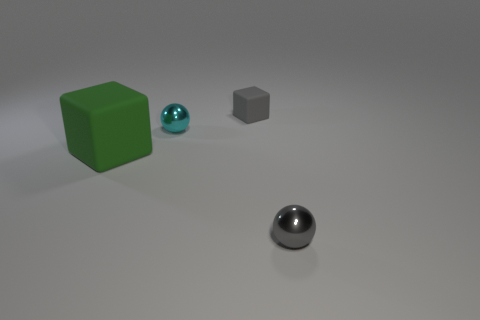What shape is the small thing that is made of the same material as the tiny gray ball?
Provide a short and direct response. Sphere. There is a large green matte thing; what number of gray shiny objects are to the right of it?
Your response must be concise. 1. Are there an equal number of green rubber blocks left of the large block and big gray rubber spheres?
Give a very brief answer. Yes. Is the small gray sphere made of the same material as the tiny cyan object?
Offer a very short reply. Yes. How big is the thing that is both left of the tiny cube and right of the big matte cube?
Your response must be concise. Small. What number of cyan shiny objects have the same size as the cyan shiny sphere?
Offer a terse response. 0. There is a metallic ball that is to the right of the gray thing behind the cyan metal object; how big is it?
Provide a short and direct response. Small. There is a object that is behind the cyan object; is it the same shape as the tiny thing that is to the right of the tiny gray block?
Your answer should be very brief. No. The object that is both right of the tiny cyan thing and behind the big thing is what color?
Your response must be concise. Gray. Are there any other big things of the same color as the large rubber thing?
Provide a succinct answer. No. 